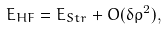Convert formula to latex. <formula><loc_0><loc_0><loc_500><loc_500>E _ { H F } = E _ { S t r } + O ( \delta \rho ^ { 2 } ) ,</formula> 